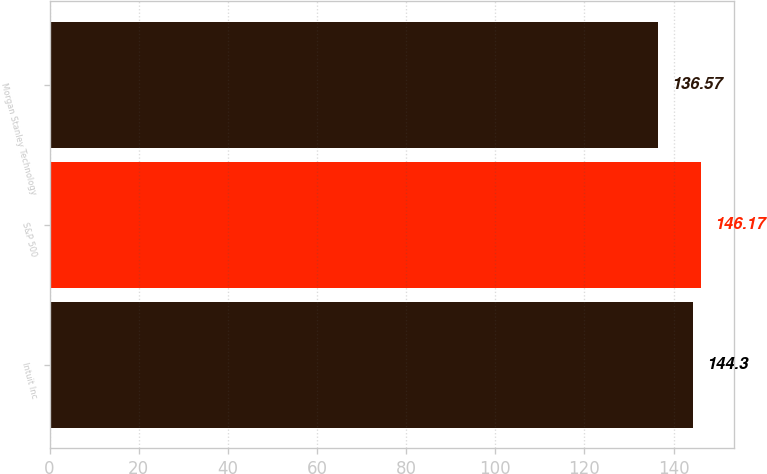Convert chart to OTSL. <chart><loc_0><loc_0><loc_500><loc_500><bar_chart><fcel>Intuit Inc<fcel>S&P 500<fcel>Morgan Stanley Technology<nl><fcel>144.3<fcel>146.17<fcel>136.57<nl></chart> 